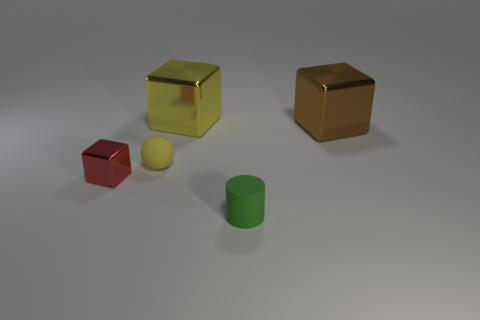There is a block that is the same size as the ball; what material is it?
Your answer should be compact. Metal. Are there an equal number of yellow blocks that are on the right side of the large yellow block and big brown shiny cubes in front of the small yellow object?
Give a very brief answer. Yes. How many brown objects are to the left of the large thing that is on the left side of the cube to the right of the green matte cylinder?
Give a very brief answer. 0. There is a matte cylinder; is its color the same as the matte object that is behind the small green thing?
Your response must be concise. No. What size is the other thing that is the same material as the tiny green object?
Your answer should be very brief. Small. Are there more yellow metal things in front of the small green thing than metallic cubes?
Provide a short and direct response. No. There is a block that is behind the metal thing that is right of the large shiny object that is on the left side of the matte cylinder; what is it made of?
Your response must be concise. Metal. Are the yellow cube and the tiny thing that is in front of the red block made of the same material?
Give a very brief answer. No. There is a big yellow thing that is the same shape as the tiny metallic thing; what is its material?
Your answer should be compact. Metal. Is there anything else that has the same material as the tiny green object?
Keep it short and to the point. Yes. 